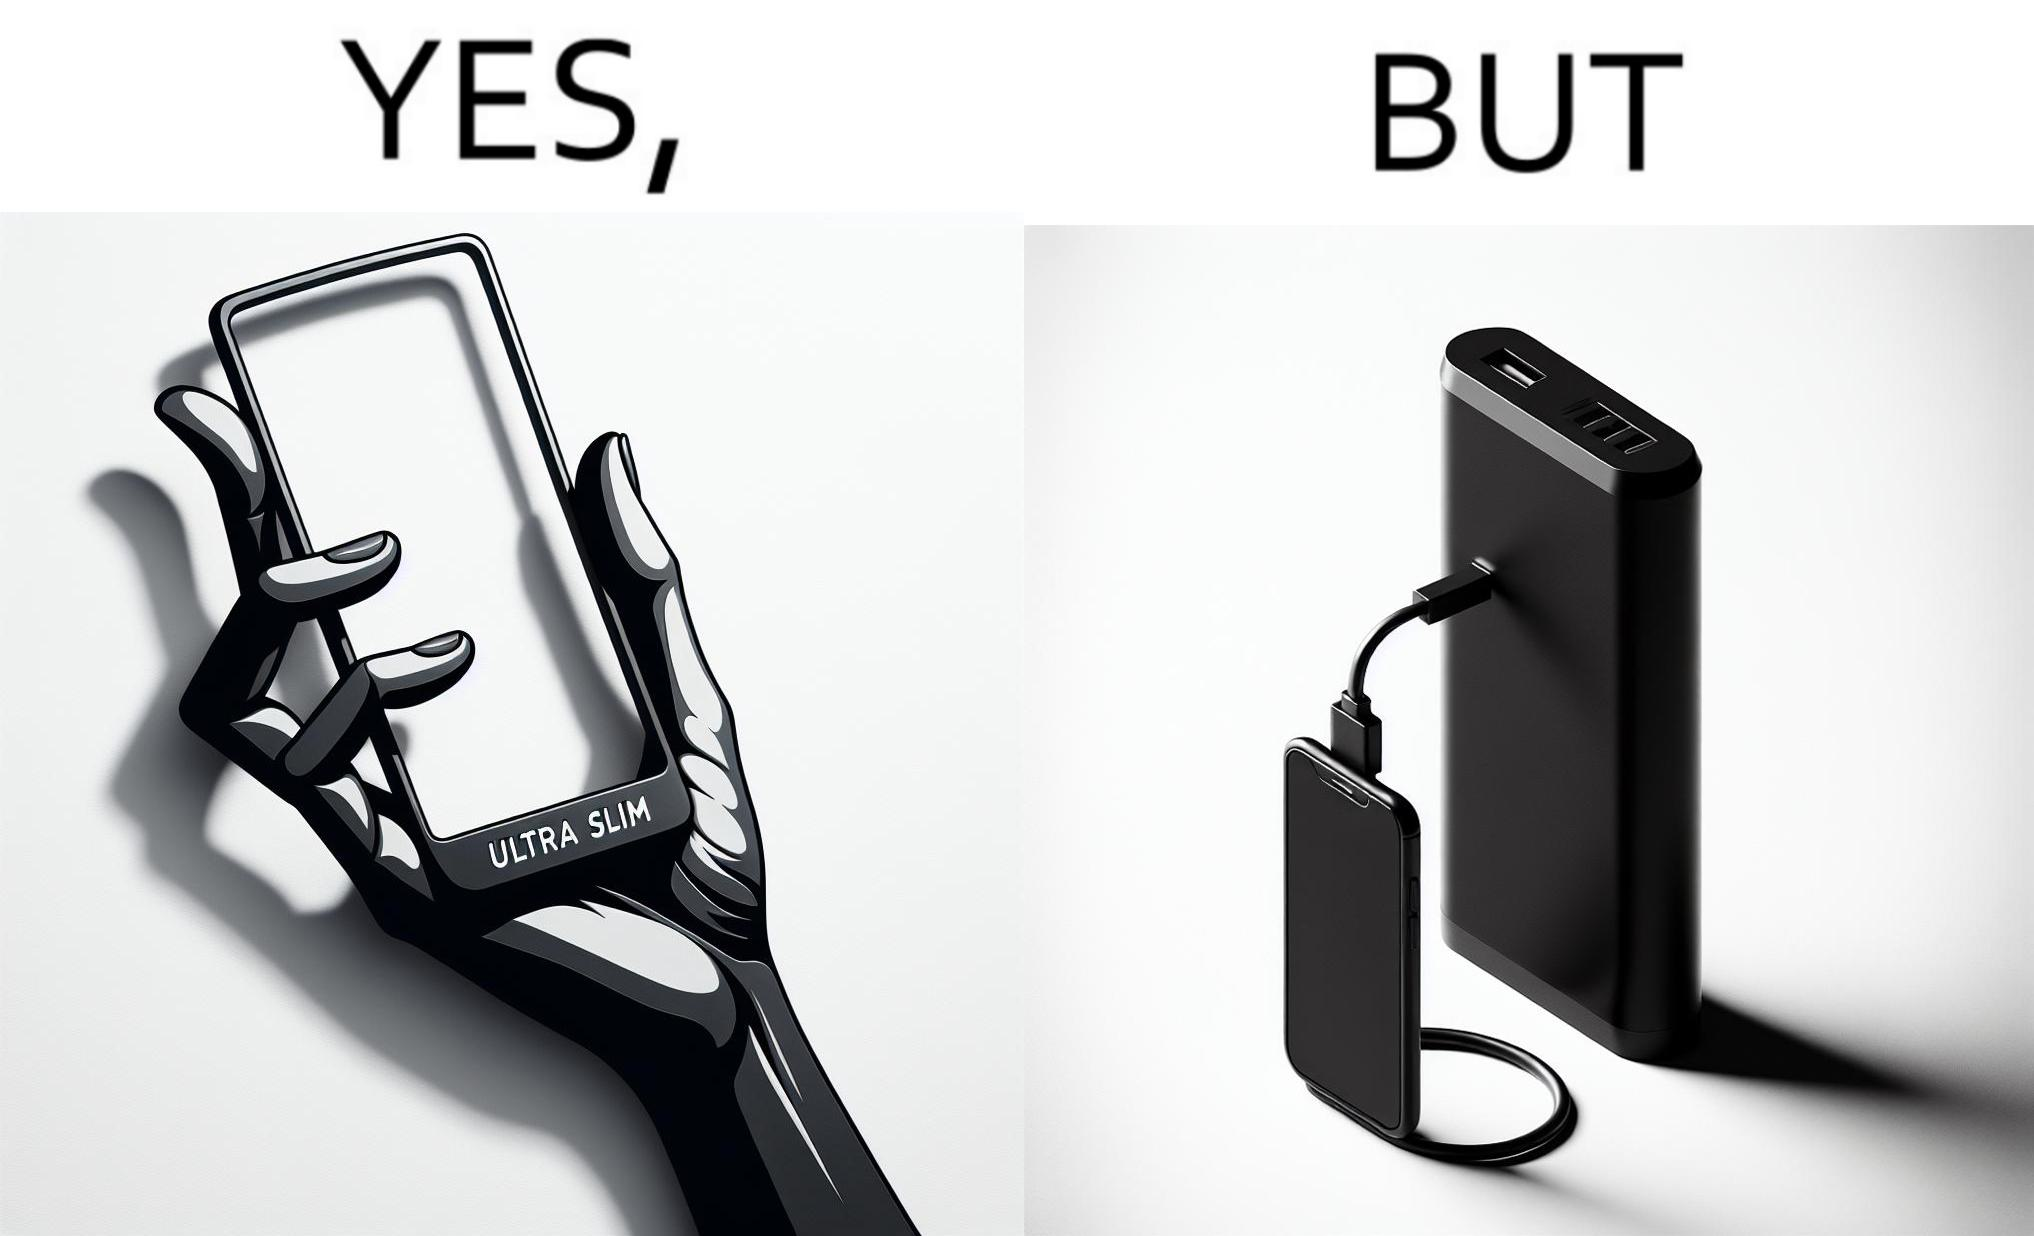Describe the contrast between the left and right parts of this image. In the left part of the image: The image shows a hand holding a mobile phone with finger tips. The text on the screen of the mobile phone says "ULTRA SLIM".  The mobile phone is indeed very slim. In the right part of the image: The image shows a slim mobile phone connected to a thick,big and heavy power bank for charging the mobile phone. 